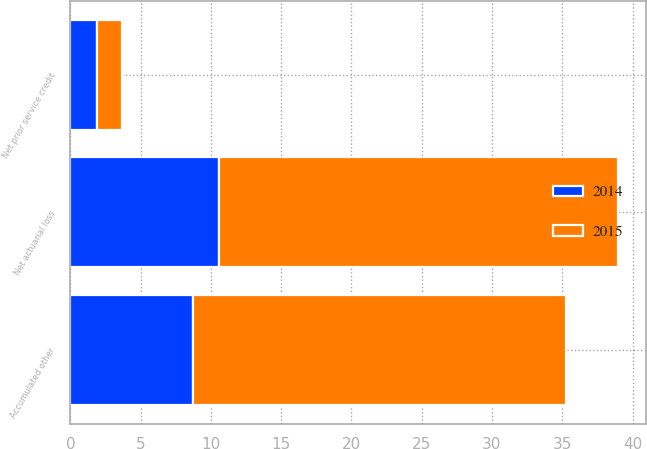Convert chart to OTSL. <chart><loc_0><loc_0><loc_500><loc_500><stacked_bar_chart><ecel><fcel>Net prior service credit<fcel>Net actuarial loss<fcel>Accumulated other<nl><fcel>2015<fcel>1.8<fcel>28.4<fcel>26.6<nl><fcel>2014<fcel>1.9<fcel>10.6<fcel>8.7<nl></chart> 